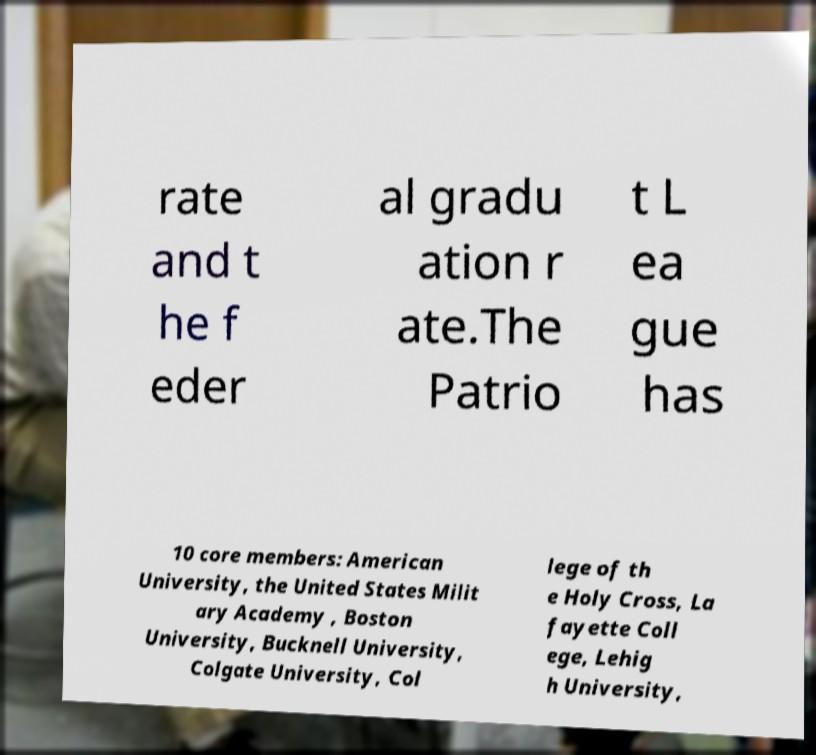Could you extract and type out the text from this image? rate and t he f eder al gradu ation r ate.The Patrio t L ea gue has 10 core members: American University, the United States Milit ary Academy , Boston University, Bucknell University, Colgate University, Col lege of th e Holy Cross, La fayette Coll ege, Lehig h University, 